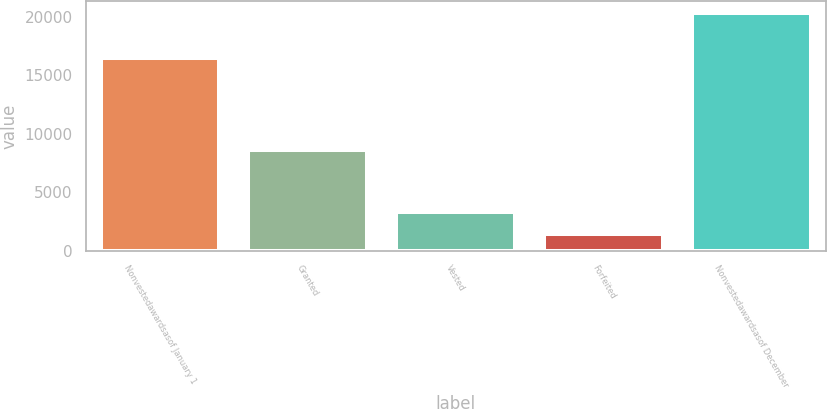Convert chart to OTSL. <chart><loc_0><loc_0><loc_500><loc_500><bar_chart><fcel>Nonvestedawardsasof January 1<fcel>Granted<fcel>Vested<fcel>Forfeited<fcel>Nonvestedawardsasof December<nl><fcel>16456<fcel>8652<fcel>3342<fcel>1430<fcel>20336<nl></chart> 